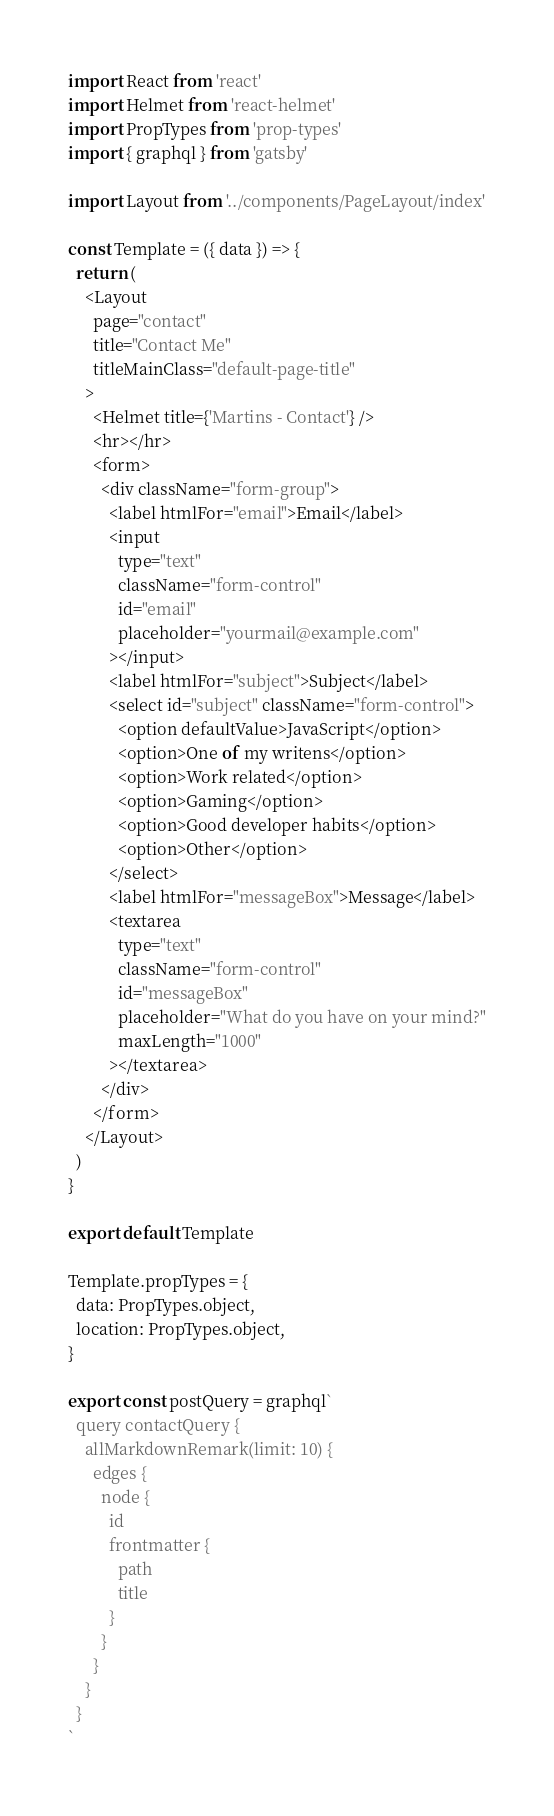Convert code to text. <code><loc_0><loc_0><loc_500><loc_500><_JavaScript_>import React from 'react'
import Helmet from 'react-helmet'
import PropTypes from 'prop-types'
import { graphql } from 'gatsby'

import Layout from '../components/PageLayout/index'

const Template = ({ data }) => {
  return (
    <Layout
      page="contact"
      title="Contact Me"
      titleMainClass="default-page-title"
    >
      <Helmet title={'Martins - Contact'} />
      <hr></hr>
      <form>
        <div className="form-group">
          <label htmlFor="email">Email</label>
          <input
            type="text"
            className="form-control"
            id="email"
            placeholder="yourmail@example.com"
          ></input>
          <label htmlFor="subject">Subject</label>
          <select id="subject" className="form-control">
            <option defaultValue>JavaScript</option>
            <option>One of my writens</option>
            <option>Work related</option>
            <option>Gaming</option>
            <option>Good developer habits</option>
            <option>Other</option>
          </select>
          <label htmlFor="messageBox">Message</label>
          <textarea
            type="text"
            className="form-control"
            id="messageBox"
            placeholder="What do you have on your mind?"
            maxLength="1000"
          ></textarea>
        </div>
      </form>
    </Layout>
  )
}

export default Template

Template.propTypes = {
  data: PropTypes.object,
  location: PropTypes.object,
}

export const postQuery = graphql`
  query contactQuery {
    allMarkdownRemark(limit: 10) {
      edges {
        node {
          id
          frontmatter {
            path
            title
          }
        }
      }
    }
  }
`
</code> 